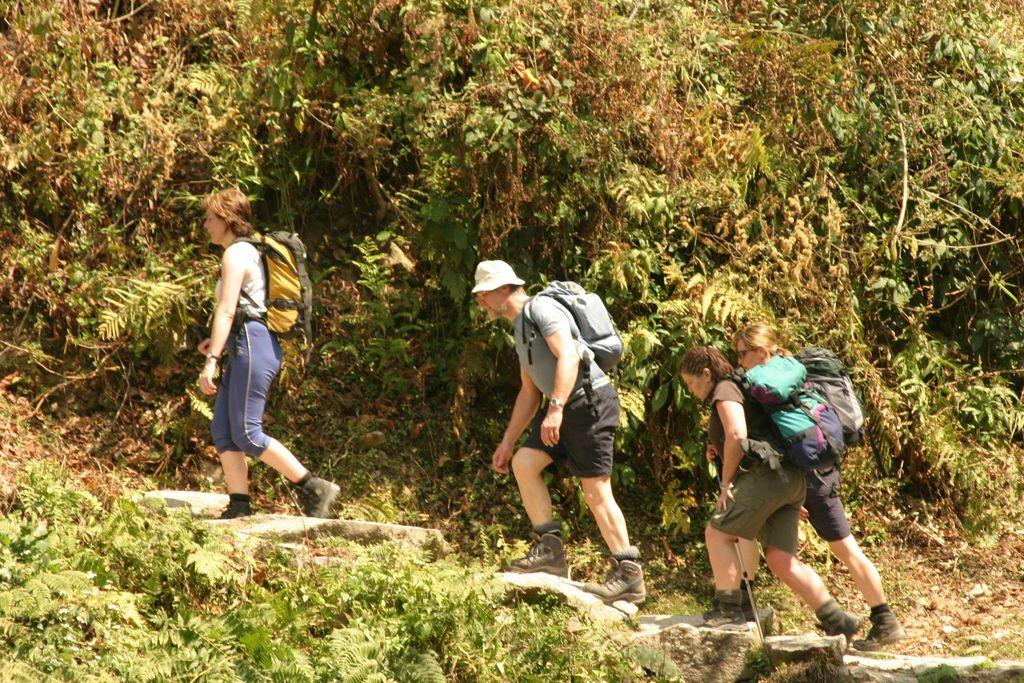What is happening in the image? There is a group of people in the image, and they are walking on a path. What are the people wearing? The people are wearing bags. What can be seen in the background of the image? There are trees in the background of the image. What shape is the comb that the people are using in the image? There is no comb present in the image. What error can be seen in the image? There is no error present in the image. 